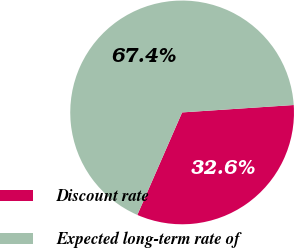Convert chart to OTSL. <chart><loc_0><loc_0><loc_500><loc_500><pie_chart><fcel>Discount rate<fcel>Expected long-term rate of<nl><fcel>32.61%<fcel>67.39%<nl></chart> 